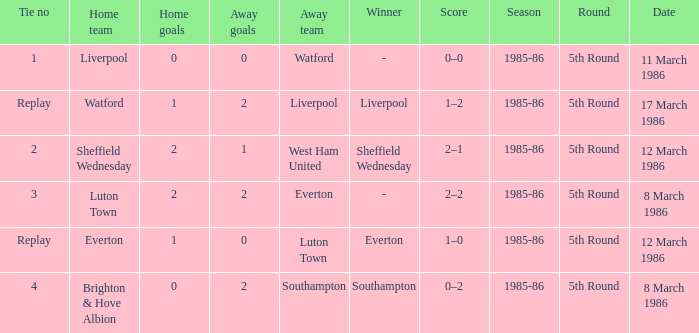What tie happened with Southampton? 4.0. 